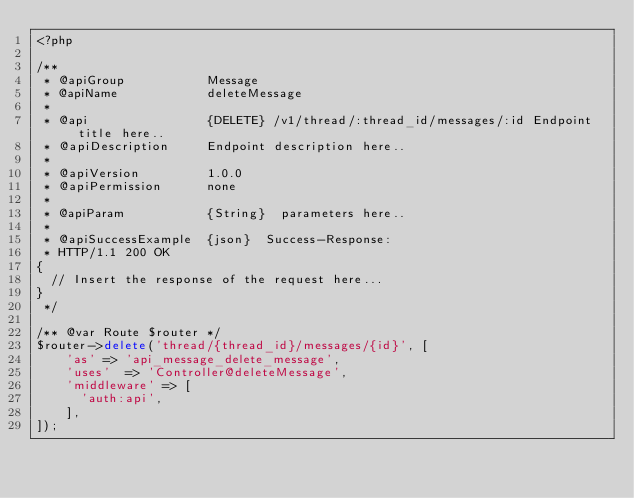Convert code to text. <code><loc_0><loc_0><loc_500><loc_500><_PHP_><?php

/**
 * @apiGroup           Message
 * @apiName            deleteMessage
 *
 * @api                {DELETE} /v1/thread/:thread_id/messages/:id Endpoint title here..
 * @apiDescription     Endpoint description here..
 *
 * @apiVersion         1.0.0
 * @apiPermission      none
 *
 * @apiParam           {String}  parameters here..
 *
 * @apiSuccessExample  {json}  Success-Response:
 * HTTP/1.1 200 OK
{
  // Insert the response of the request here...
}
 */

/** @var Route $router */
$router->delete('thread/{thread_id}/messages/{id}', [
    'as' => 'api_message_delete_message',
    'uses'  => 'Controller@deleteMessage',
    'middleware' => [
      'auth:api',
    ],
]);
</code> 